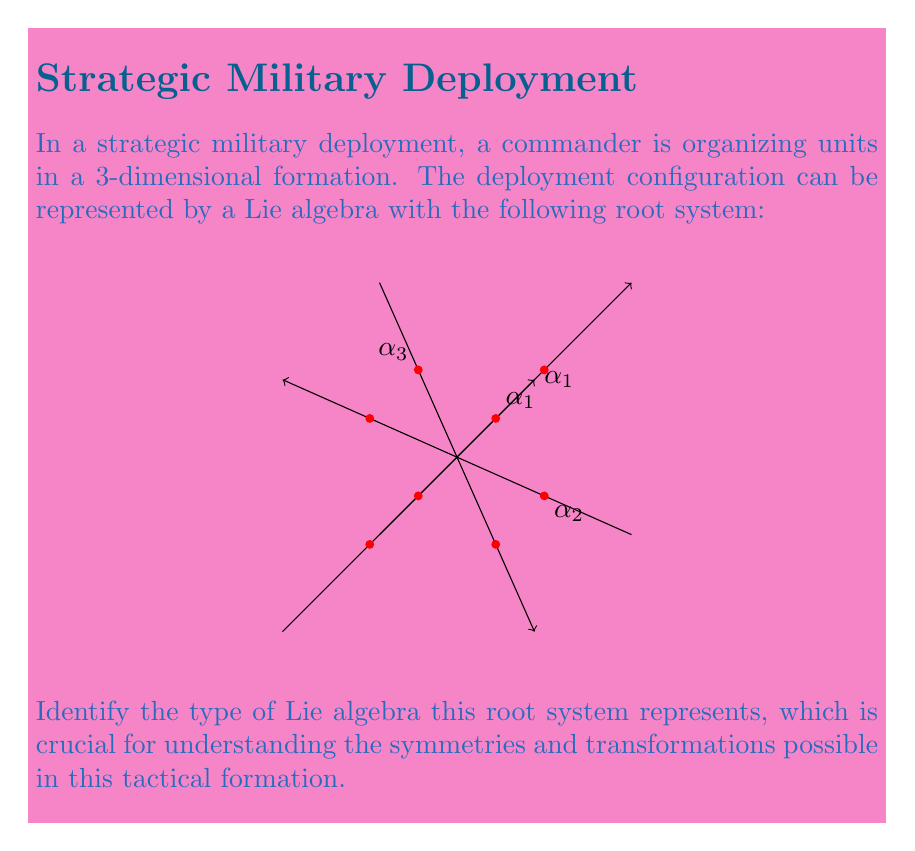Help me with this question. To identify the Lie algebra from its root system, we need to analyze the structure and relationships of the roots:

1. Observe that there are 8 vertices in the diagram, representing the roots of the system.

2. The roots form a cube in 3-dimensional space, with vertices at the coordinates $(\pm1, \pm1, \pm1)$.

3. There are three simple roots, labeled $\alpha_1$, $\alpha_2$, and $\alpha_3$, which form a basis for the root system.

4. The angles between these simple roots are all 90 degrees, forming an orthogonal system.

5. All roots in the system can be expressed as integer linear combinations of these simple roots.

6. The highest root in this system is $\alpha_1 + \alpha_2 + \alpha_3$.

7. This configuration of roots, forming a cube with orthogonal simple roots, is characteristic of the $B_3$ root system.

8. The $B_3$ root system corresponds to the Lie algebra $\mathfrak{so}(7)$, which is the special orthogonal Lie algebra in 7 dimensions.

9. In military context, $\mathfrak{so}(7)$ represents rotations and reflections in 7-dimensional space, which can be interpreted as complex maneuvers and transformations of the 3D tactical formation.

Therefore, the Lie algebra represented by this root system is $\mathfrak{so}(7)$, also known as the $B_3$ Lie algebra.
Answer: $\mathfrak{so}(7)$ (or $B_3$) 